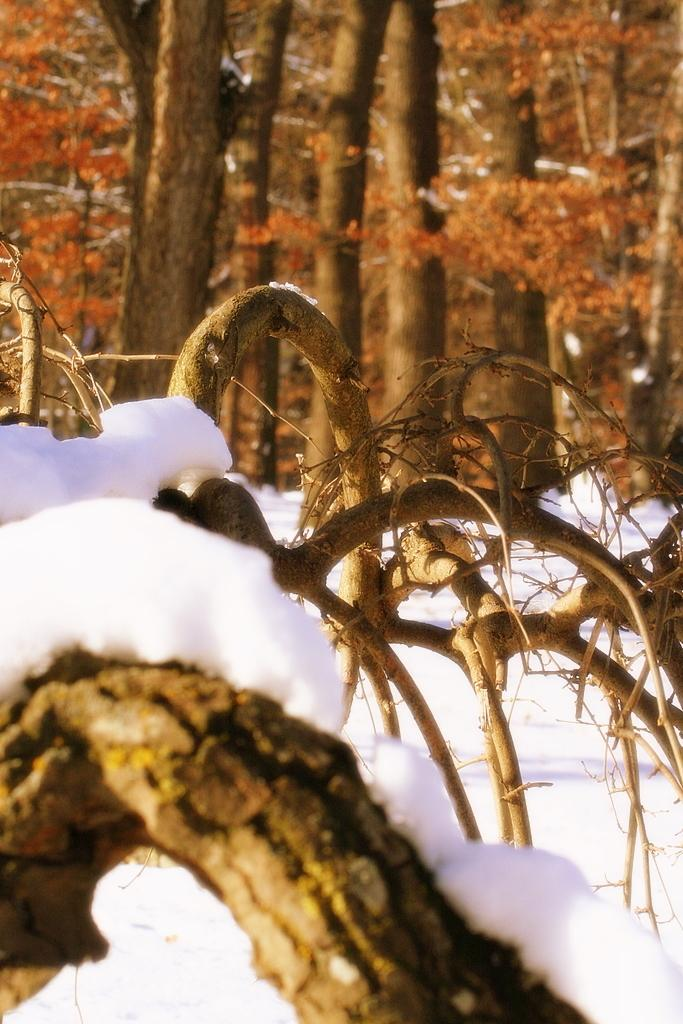What is located at the bottom of the picture? There is a tree at the bottom of the picture. What is the condition of the tree at the bottom of the picture? The tree is covered with ice. What can be seen in the background of the image? There are many trees in the background of the image. How does the tree increase its height in the image? The tree does not increase its height in the image; it is already fully grown and covered with ice. 